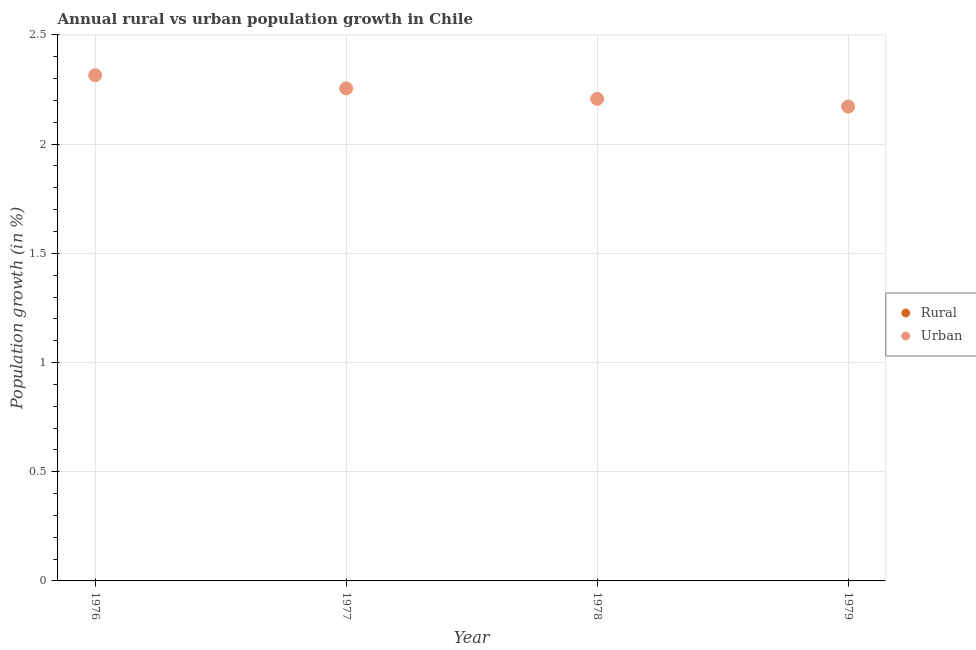How many different coloured dotlines are there?
Keep it short and to the point. 1. Is the number of dotlines equal to the number of legend labels?
Your answer should be compact. No. Across all years, what is the maximum urban population growth?
Your response must be concise. 2.32. Across all years, what is the minimum urban population growth?
Provide a succinct answer. 2.17. In which year was the urban population growth maximum?
Your response must be concise. 1976. What is the difference between the urban population growth in 1977 and that in 1979?
Provide a short and direct response. 0.08. What is the difference between the urban population growth in 1978 and the rural population growth in 1976?
Provide a short and direct response. 2.21. What is the average rural population growth per year?
Provide a succinct answer. 0. In how many years, is the rural population growth greater than 1.3 %?
Provide a succinct answer. 0. What is the ratio of the urban population growth in 1978 to that in 1979?
Your answer should be compact. 1.02. What is the difference between the highest and the second highest urban population growth?
Provide a short and direct response. 0.06. What is the difference between the highest and the lowest urban population growth?
Offer a terse response. 0.14. Is the sum of the urban population growth in 1977 and 1979 greater than the maximum rural population growth across all years?
Make the answer very short. Yes. Is the rural population growth strictly less than the urban population growth over the years?
Your answer should be compact. Yes. How many dotlines are there?
Give a very brief answer. 1. How many years are there in the graph?
Ensure brevity in your answer.  4. Are the values on the major ticks of Y-axis written in scientific E-notation?
Make the answer very short. No. Does the graph contain grids?
Provide a succinct answer. Yes. Where does the legend appear in the graph?
Provide a succinct answer. Center right. What is the title of the graph?
Your answer should be compact. Annual rural vs urban population growth in Chile. Does "Under-five" appear as one of the legend labels in the graph?
Provide a succinct answer. No. What is the label or title of the Y-axis?
Your response must be concise. Population growth (in %). What is the Population growth (in %) in Urban  in 1976?
Your answer should be compact. 2.32. What is the Population growth (in %) of Rural in 1977?
Your answer should be very brief. 0. What is the Population growth (in %) of Urban  in 1977?
Keep it short and to the point. 2.26. What is the Population growth (in %) of Urban  in 1978?
Provide a short and direct response. 2.21. What is the Population growth (in %) in Rural in 1979?
Give a very brief answer. 0. What is the Population growth (in %) in Urban  in 1979?
Offer a very short reply. 2.17. Across all years, what is the maximum Population growth (in %) in Urban ?
Offer a terse response. 2.32. Across all years, what is the minimum Population growth (in %) of Urban ?
Give a very brief answer. 2.17. What is the total Population growth (in %) of Urban  in the graph?
Your response must be concise. 8.95. What is the difference between the Population growth (in %) in Urban  in 1976 and that in 1977?
Offer a terse response. 0.06. What is the difference between the Population growth (in %) of Urban  in 1976 and that in 1978?
Provide a succinct answer. 0.11. What is the difference between the Population growth (in %) of Urban  in 1976 and that in 1979?
Your answer should be compact. 0.14. What is the difference between the Population growth (in %) of Urban  in 1977 and that in 1978?
Provide a succinct answer. 0.05. What is the difference between the Population growth (in %) in Urban  in 1977 and that in 1979?
Your answer should be compact. 0.08. What is the difference between the Population growth (in %) of Urban  in 1978 and that in 1979?
Offer a terse response. 0.04. What is the average Population growth (in %) of Urban  per year?
Offer a terse response. 2.24. What is the ratio of the Population growth (in %) in Urban  in 1976 to that in 1977?
Offer a very short reply. 1.03. What is the ratio of the Population growth (in %) in Urban  in 1976 to that in 1978?
Ensure brevity in your answer.  1.05. What is the ratio of the Population growth (in %) in Urban  in 1976 to that in 1979?
Offer a very short reply. 1.07. What is the ratio of the Population growth (in %) in Urban  in 1977 to that in 1978?
Offer a very short reply. 1.02. What is the ratio of the Population growth (in %) in Urban  in 1977 to that in 1979?
Keep it short and to the point. 1.04. What is the ratio of the Population growth (in %) in Urban  in 1978 to that in 1979?
Keep it short and to the point. 1.02. What is the difference between the highest and the second highest Population growth (in %) of Urban ?
Offer a terse response. 0.06. What is the difference between the highest and the lowest Population growth (in %) of Urban ?
Provide a succinct answer. 0.14. 